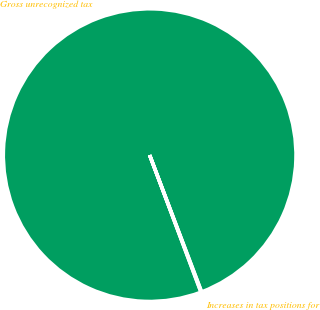Convert chart to OTSL. <chart><loc_0><loc_0><loc_500><loc_500><pie_chart><fcel>Gross unrecognized tax<fcel>Increases in tax positions for<nl><fcel>99.92%<fcel>0.08%<nl></chart> 